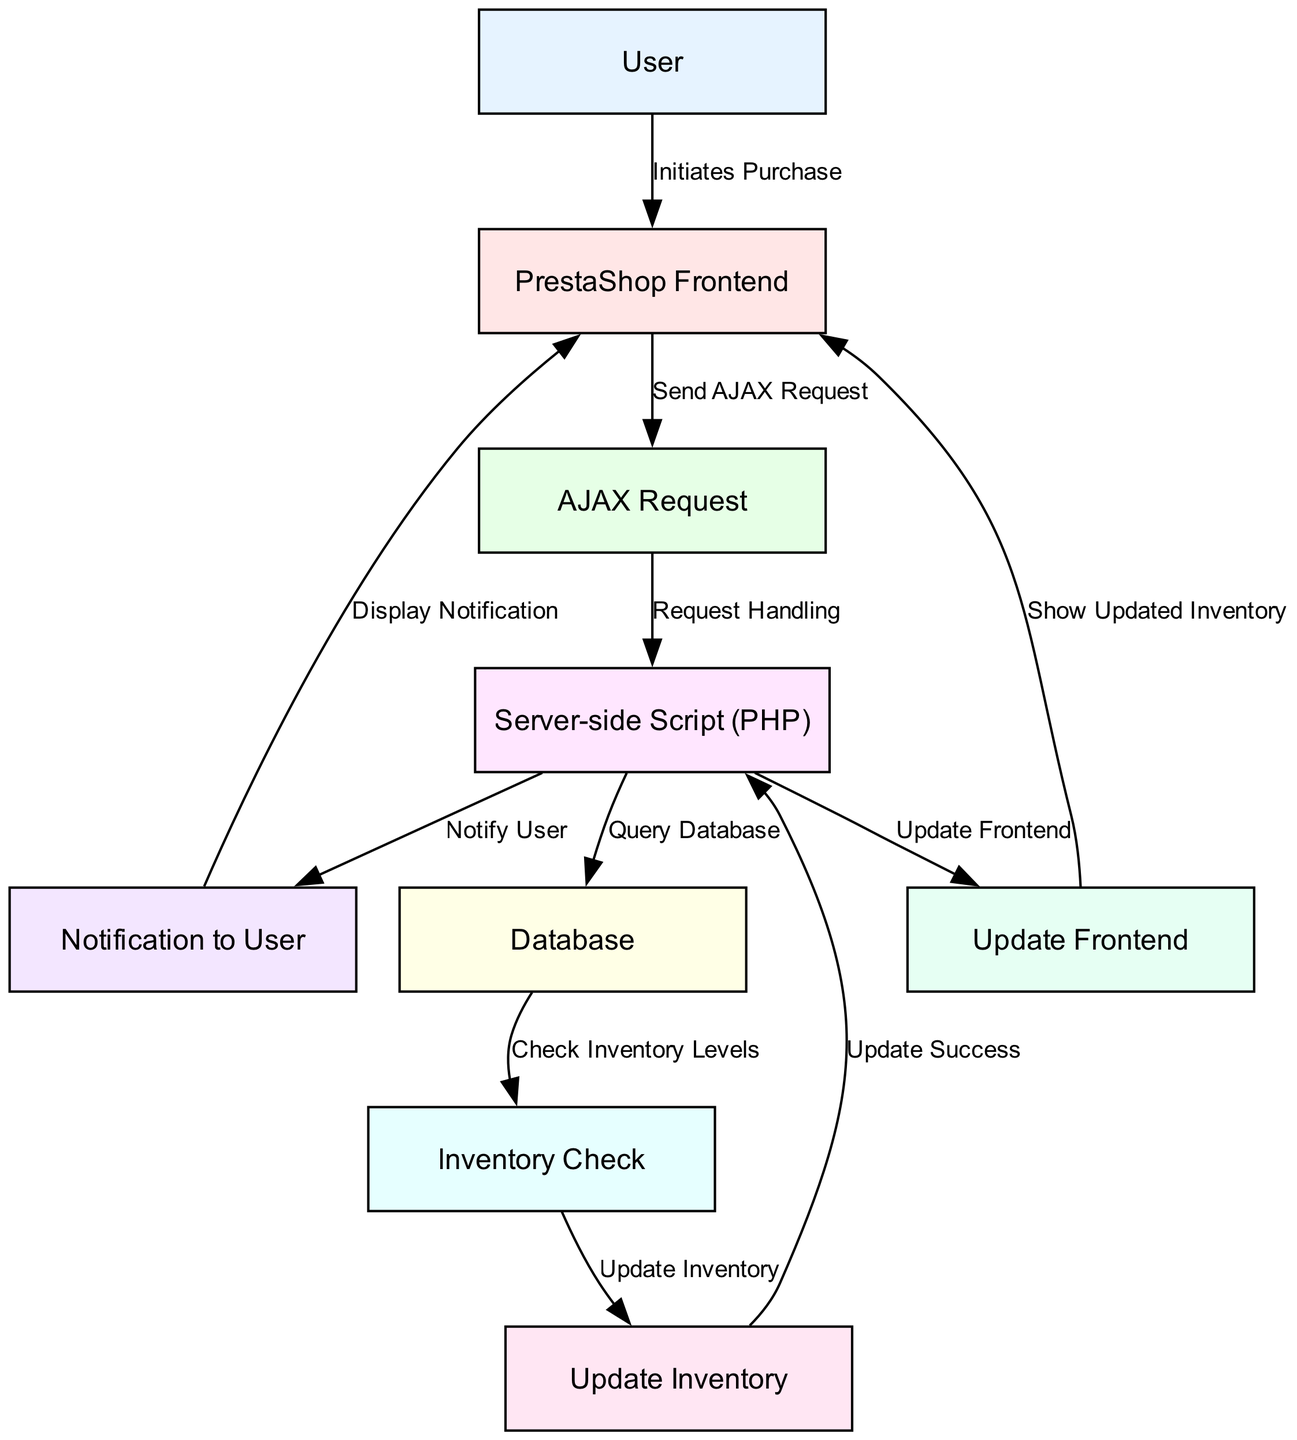What is the total number of nodes in the diagram? The diagram lists a total of 9 nodes representing different entities or processes in the real-time inventory management system. These nodes are User, PrestaShop Frontend, AJAX Request, Server-side Script (PHP), Database, Inventory Check, Update Inventory, Notification to User, and Update Frontend. Counting each distinct node leads to a total of 9.
Answer: 9 What node initiates the purchase? The node labeled "User" represents the individual who initiates the purchase process. The edge connecting the User to the PrestaShop Frontend indicates the initiation of this process.
Answer: User How many edges are in the diagram? The diagram contains a total of 10 edges that represent the various connections and interactions between the nodes. By reviewing the edges from the data, we find each pair of nodes that are connected, leading to a count of 10.
Answer: 10 What is the relationship between "Server-side Script (PHP)" and "Database"? The edge labeled "Query Database" illustrates the relationship between the "Server-side Script (PHP)" and "Database". This indicates that the server-side script is responsible for querying the database to retrieve or manipulate data related to inventory management.
Answer: Query Database What happens after the "Update Inventory" node? After the "Update Inventory" node, the process loops back to the "Server-side Script (PHP)" node with the edge labeled "Update Success", showing that once the inventory is updated, the server-side script is involved again, likely to handle the next steps such as notifying the user or updating the frontend.
Answer: Update Success What type of notification is sent to the user? The diagram indicates that the notification sent to the user is labeled "Notify User". This step occurs after the server-side script processes the inventory update and communicates this change back to the user.
Answer: Notify User How does the user see the updated inventory? The user sees the updated inventory via the edge labeled "Show Updated Inventory", which connects the "Update Frontend" node back to the "PrestaShop Frontend". This indicates that the updated data is reflected on the frontend for the user to view.
Answer: Show Updated Inventory What action does the "AJAX Request" node perform? The "AJAX Request" node performs the action of "Request Handling". It represents the mechanism where the frontend sends a request to the server-side script for handling inventory-related tasks, facilitating asynchronous communication without needing to reload the page.
Answer: Request Handling Where does the inventory checking process occur? The inventory checking process occurs in the "Inventory Check" node, which is executed after the server-side script queries the database. This is a crucial step for determining if the requested inventory is available.
Answer: Inventory Check 